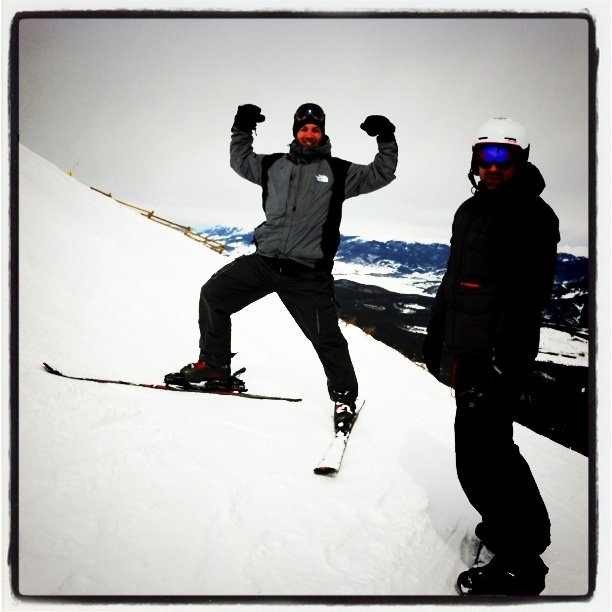Describe the objects in this image and their specific colors. I can see people in white, black, lightgray, darkgray, and gray tones, people in white, black, and purple tones, skis in white, black, gray, and darkgray tones, and snowboard in white, gray, and black tones in this image. 